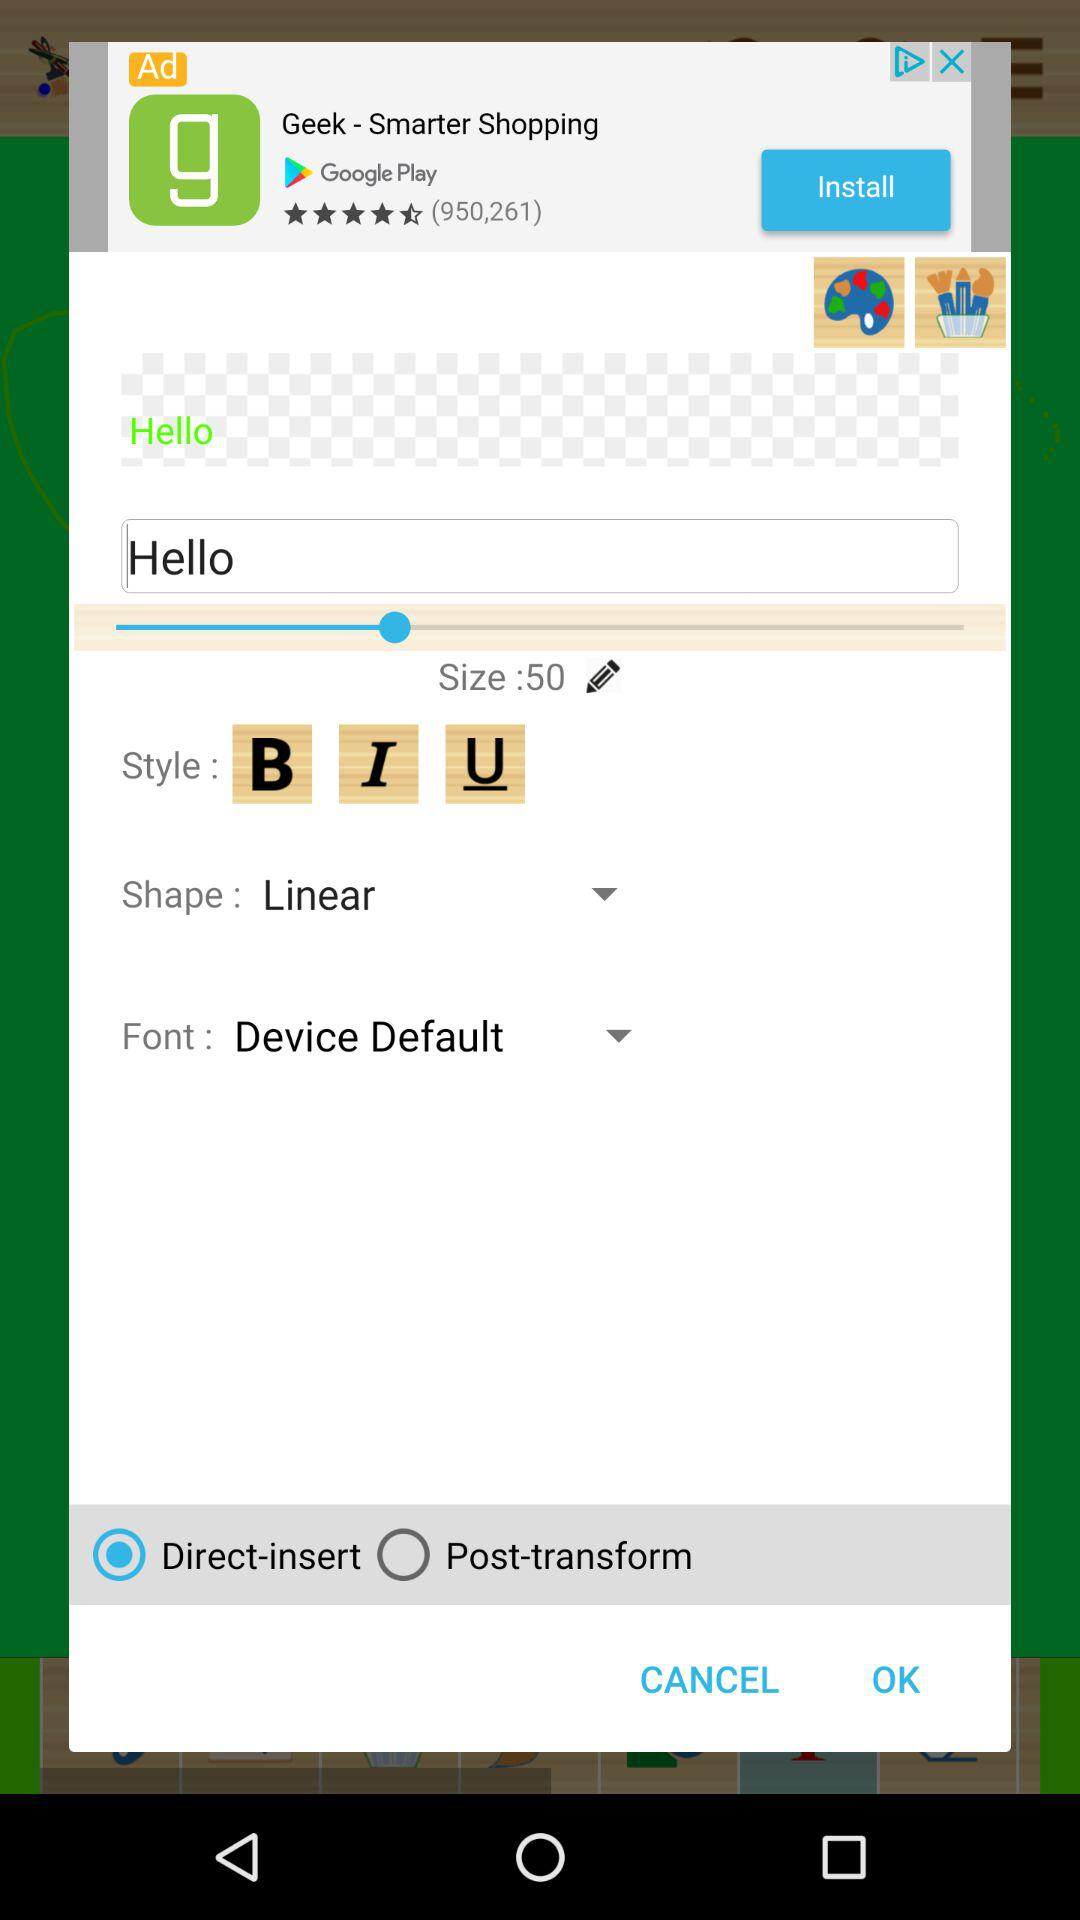What is the text size number? The text size number is 50. 